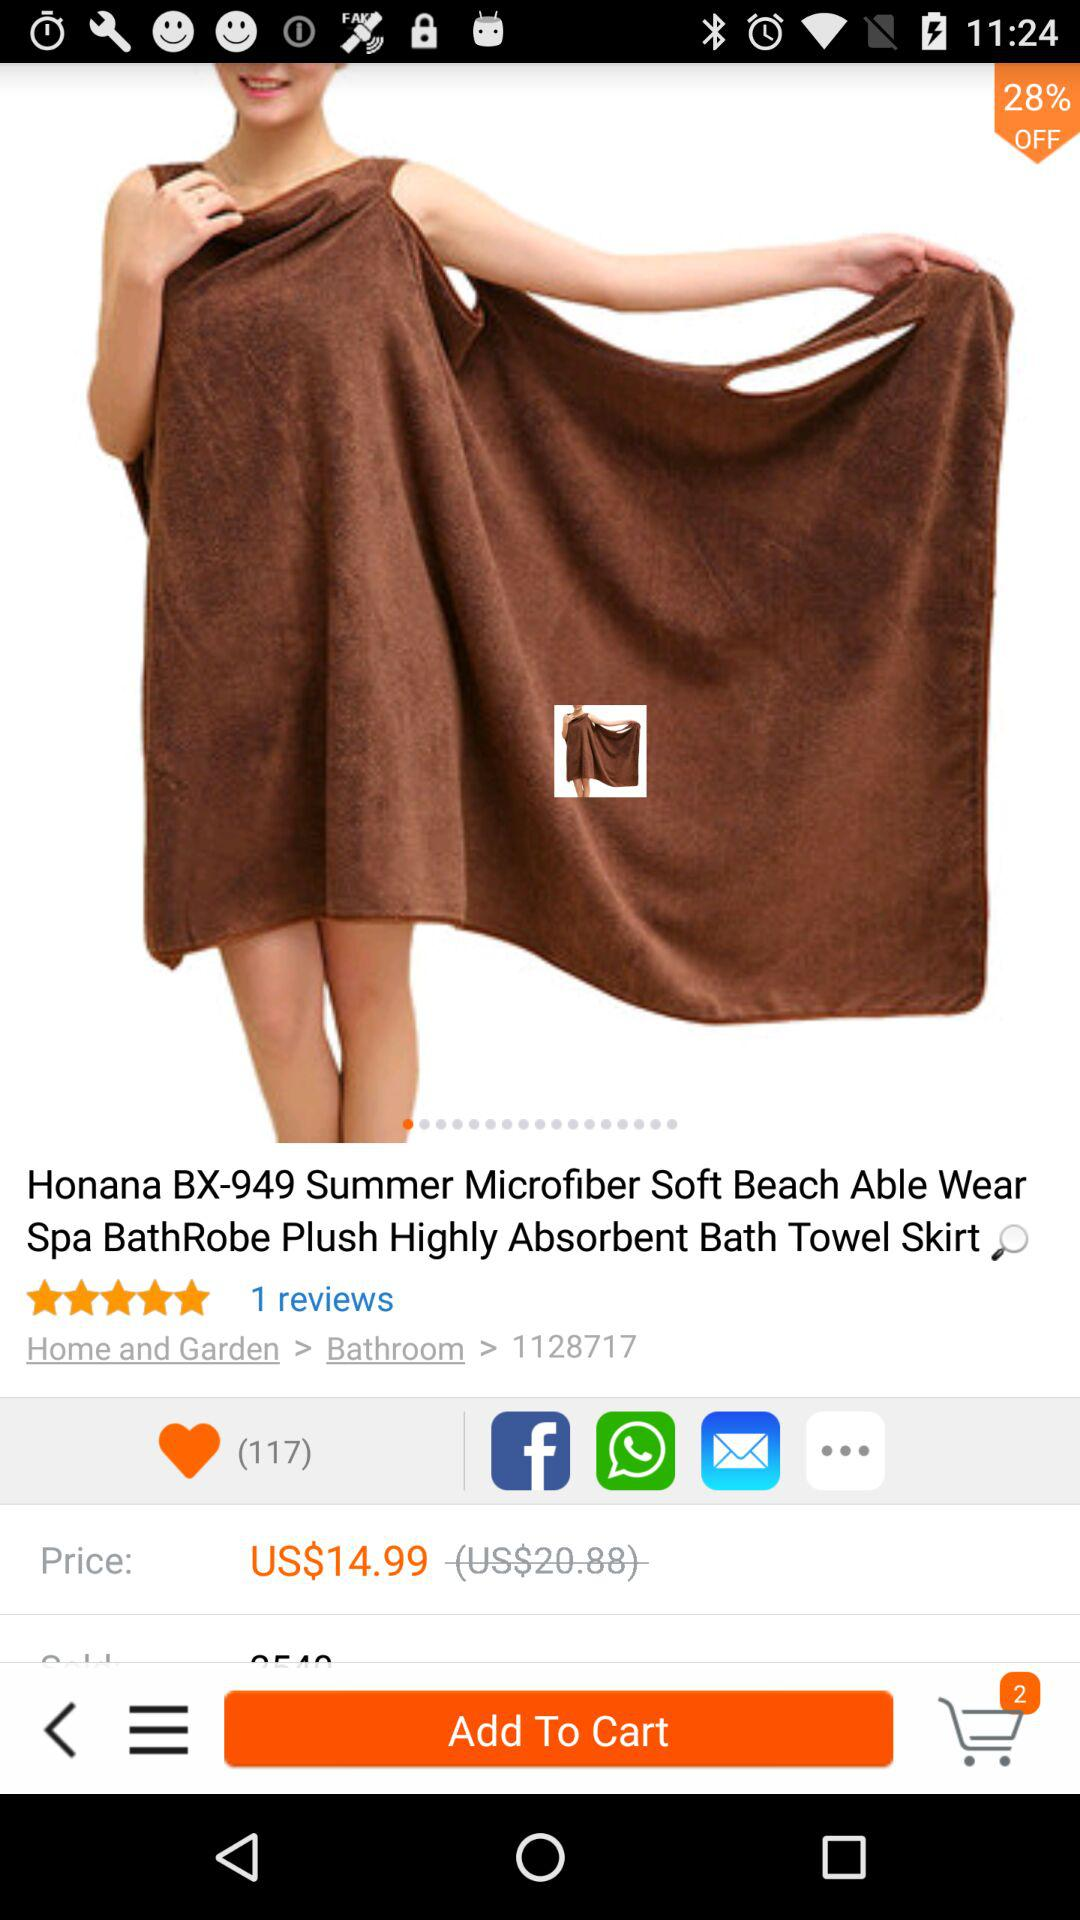How many reviews are given for "Honana BX-949 Summer Microfiber Soft Beach Able Wear Spa BathRobe Plush Highly Absorbent Bath Towel Skirt"? There is 1 review. 